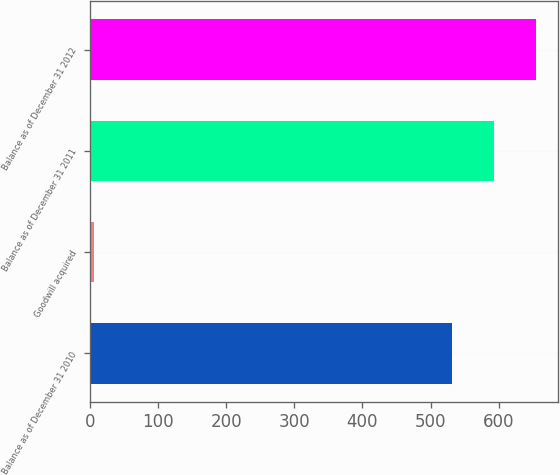<chart> <loc_0><loc_0><loc_500><loc_500><bar_chart><fcel>Balance as of December 31 2010<fcel>Goodwill acquired<fcel>Balance as of December 31 2011<fcel>Balance as of December 31 2012<nl><fcel>531<fcel>5<fcel>592.8<fcel>654.6<nl></chart> 